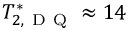Convert formula to latex. <formula><loc_0><loc_0><loc_500><loc_500>T _ { 2 , D Q } ^ { * } \approx 1 4</formula> 